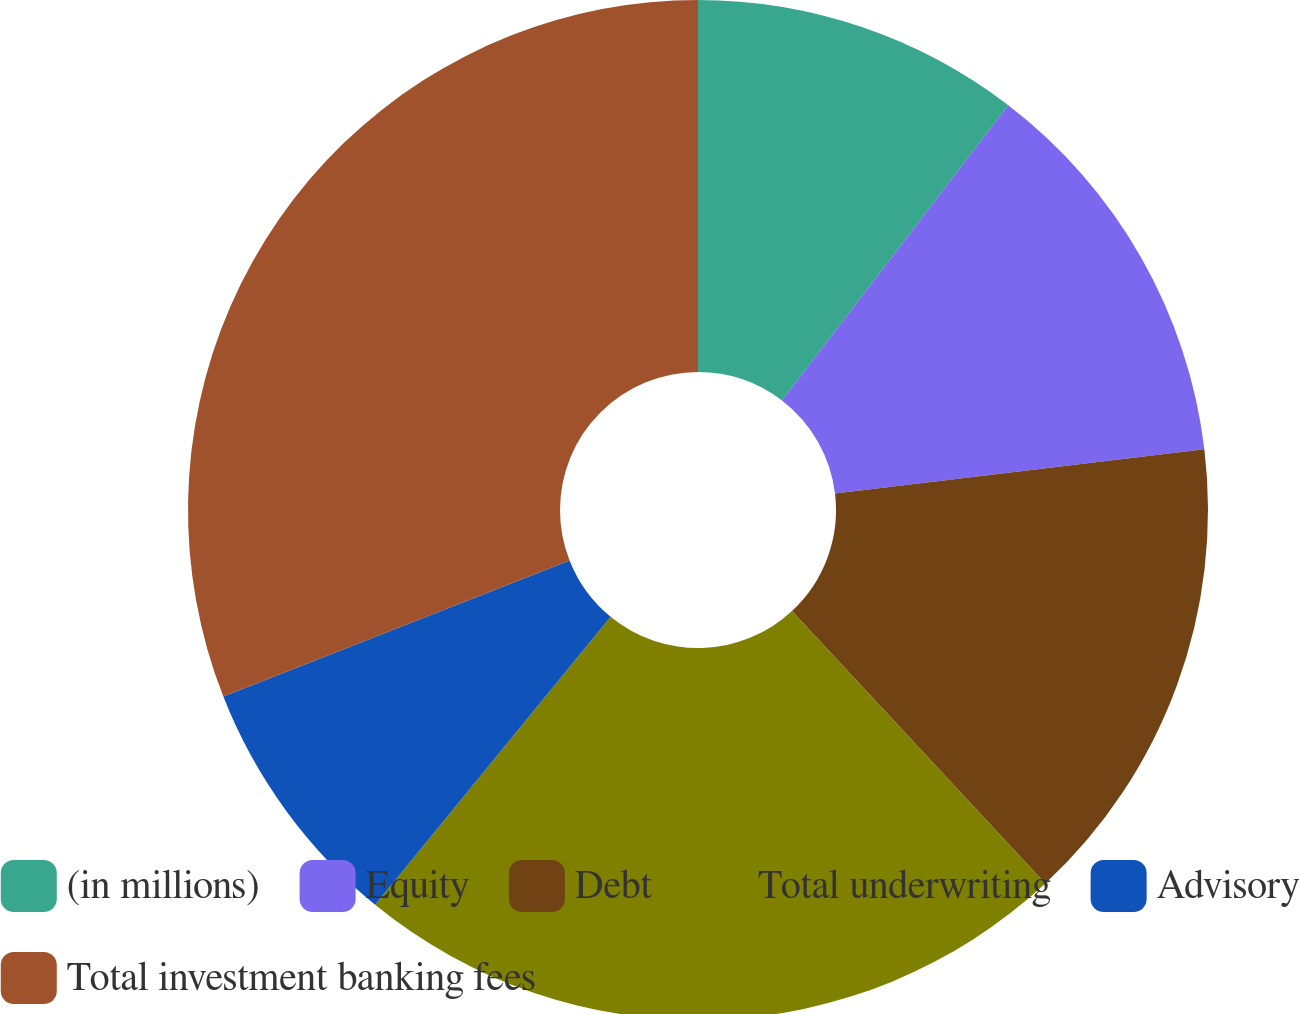Convert chart to OTSL. <chart><loc_0><loc_0><loc_500><loc_500><pie_chart><fcel>(in millions)<fcel>Equity<fcel>Debt<fcel>Total underwriting<fcel>Advisory<fcel>Total investment banking fees<nl><fcel>10.41%<fcel>12.69%<fcel>14.98%<fcel>22.83%<fcel>8.13%<fcel>30.96%<nl></chart> 